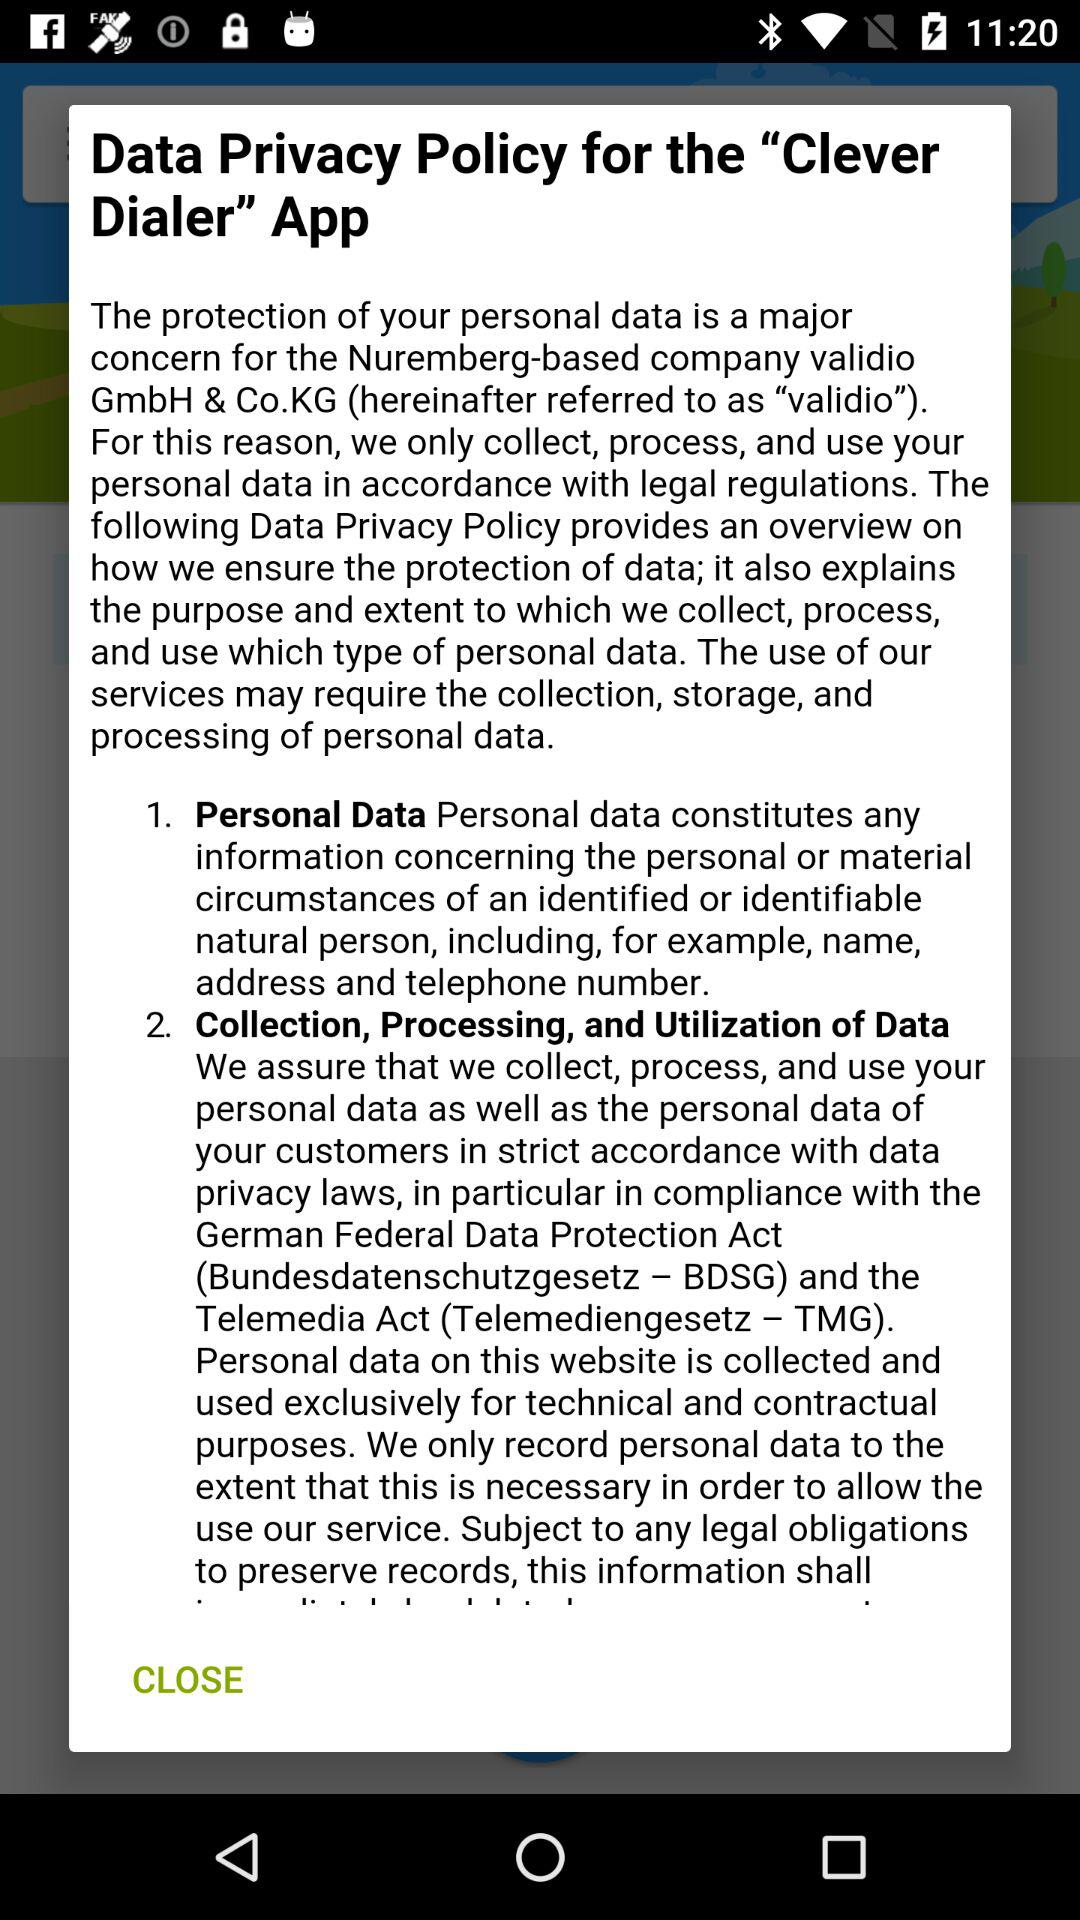What is the application name? The application name is "Clever Dialer". 